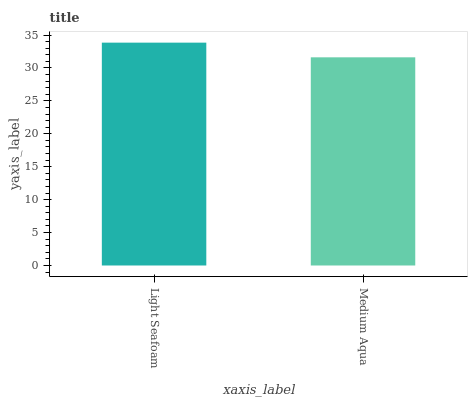Is Medium Aqua the maximum?
Answer yes or no. No. Is Light Seafoam greater than Medium Aqua?
Answer yes or no. Yes. Is Medium Aqua less than Light Seafoam?
Answer yes or no. Yes. Is Medium Aqua greater than Light Seafoam?
Answer yes or no. No. Is Light Seafoam less than Medium Aqua?
Answer yes or no. No. Is Light Seafoam the high median?
Answer yes or no. Yes. Is Medium Aqua the low median?
Answer yes or no. Yes. Is Medium Aqua the high median?
Answer yes or no. No. Is Light Seafoam the low median?
Answer yes or no. No. 